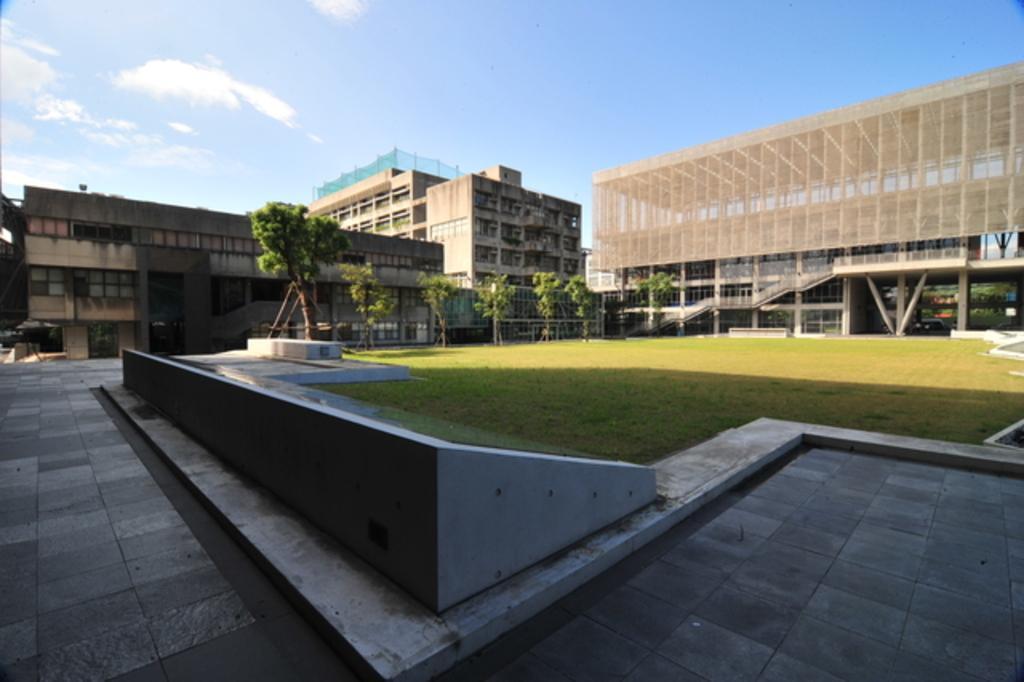Can you describe this image briefly? In this image I can see the ground, some grass, few trees and few buildings. In the background I can see the sky. 